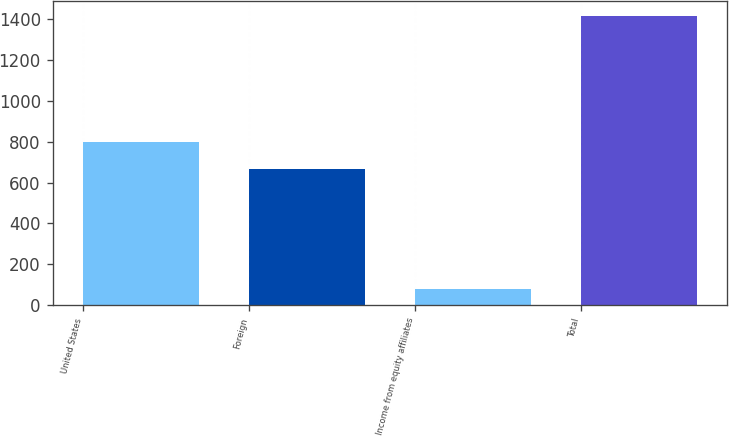Convert chart. <chart><loc_0><loc_0><loc_500><loc_500><bar_chart><fcel>United States<fcel>Foreign<fcel>Income from equity affiliates<fcel>Total<nl><fcel>799.8<fcel>666.2<fcel>80.1<fcel>1416.1<nl></chart> 